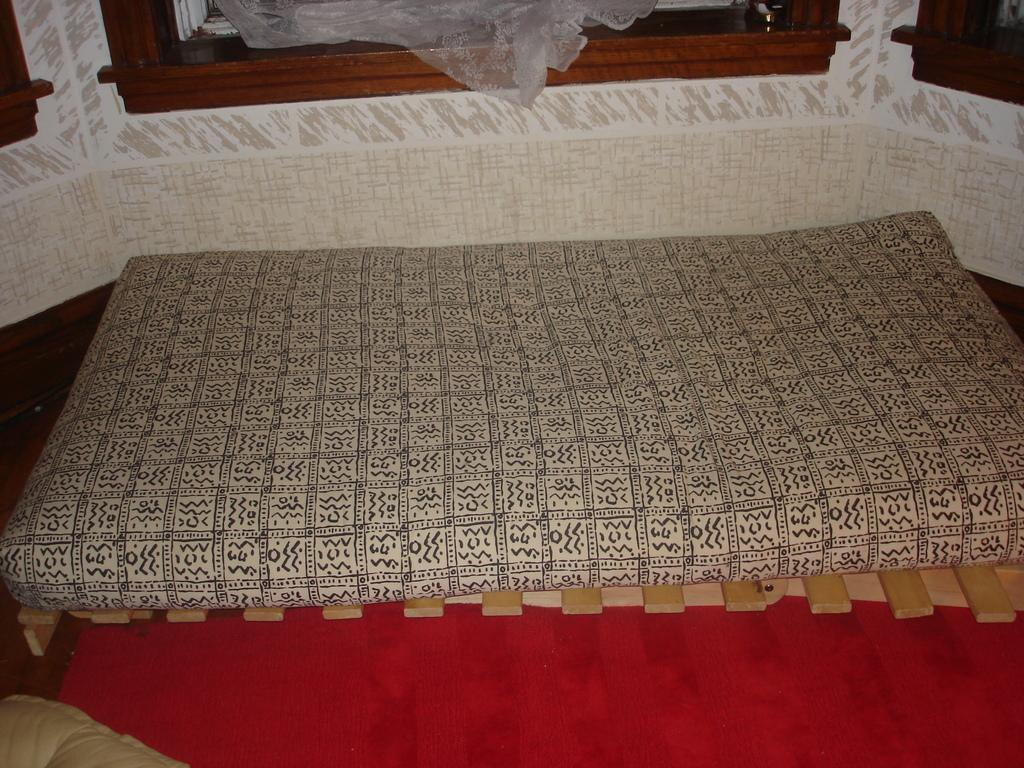What type of furniture is present in the image? There is a bed in the image. What color is the bed? The bed is cream-colored. What can be seen in the background of the image? The background of the image includes a wall. What colors are used for the wall? The wall is in cream and white colors. Can you tell me how many times the bed swings in the image? There is no indication that the bed is swinging in the image; it is stationary. What thought is being expressed by the bed in the image? The bed is an inanimate object and cannot express thoughts. 